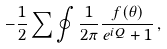<formula> <loc_0><loc_0><loc_500><loc_500>- \frac { 1 } { 2 } \sum \oint \frac { 1 } { 2 \pi } \frac { f ( \theta ) } { e ^ { i Q } + 1 } \, ,</formula> 